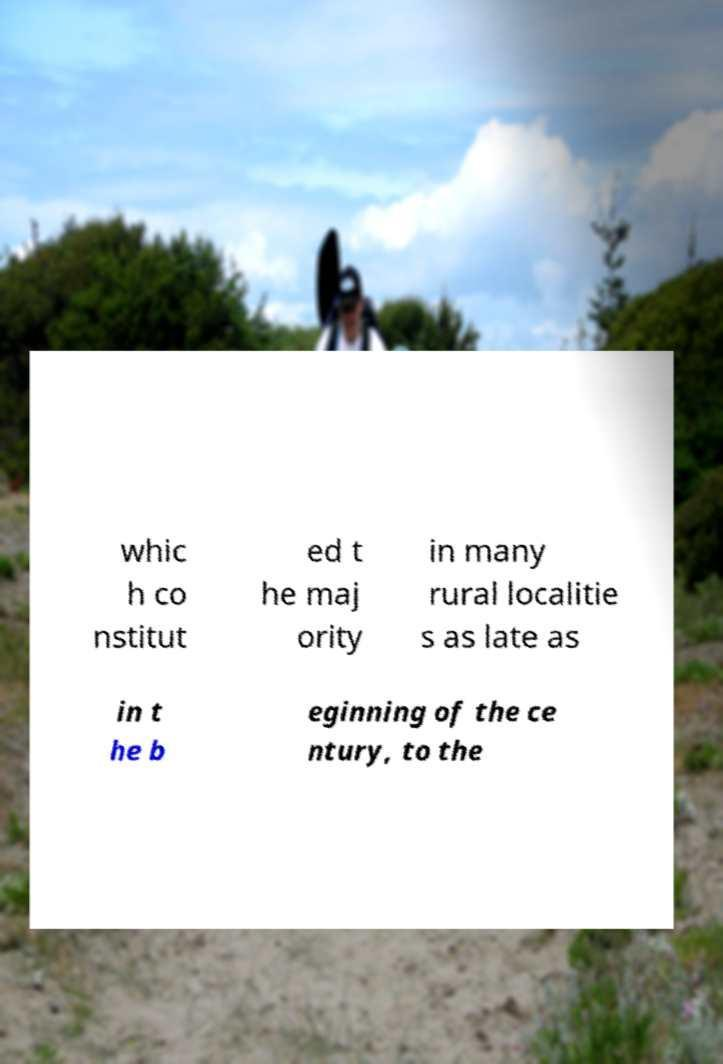Could you extract and type out the text from this image? whic h co nstitut ed t he maj ority in many rural localitie s as late as in t he b eginning of the ce ntury, to the 